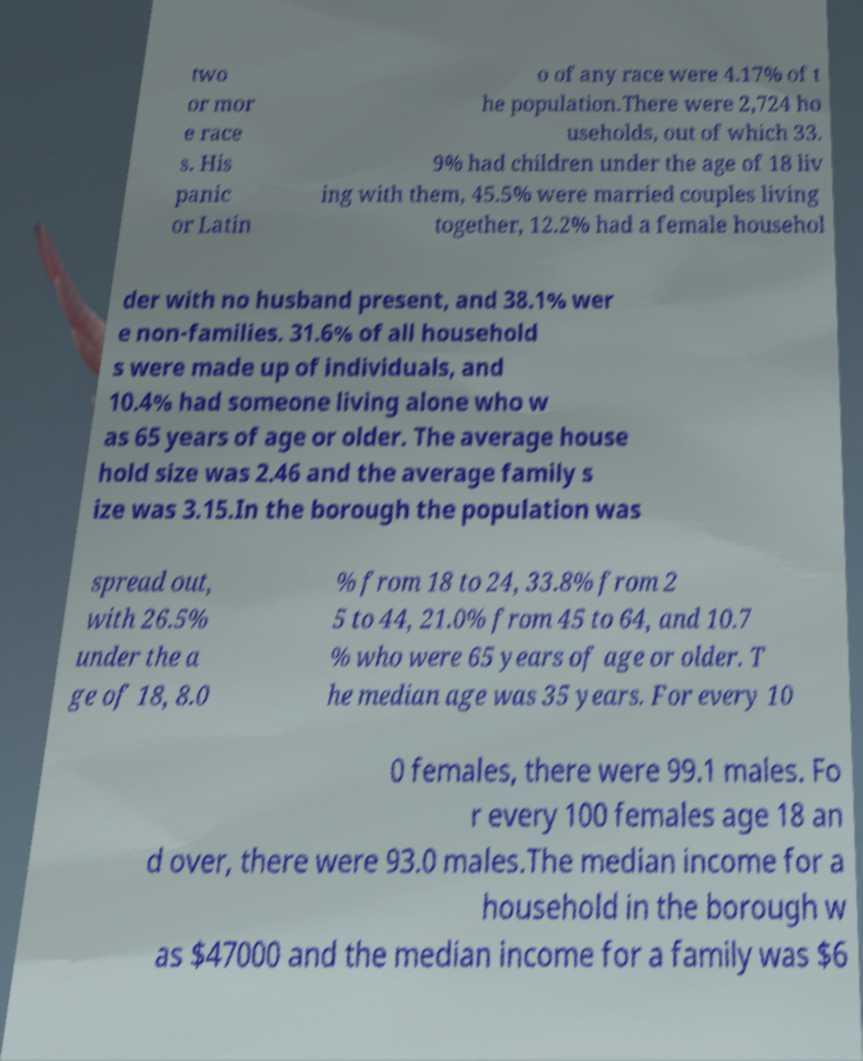There's text embedded in this image that I need extracted. Can you transcribe it verbatim? two or mor e race s. His panic or Latin o of any race were 4.17% of t he population.There were 2,724 ho useholds, out of which 33. 9% had children under the age of 18 liv ing with them, 45.5% were married couples living together, 12.2% had a female househol der with no husband present, and 38.1% wer e non-families. 31.6% of all household s were made up of individuals, and 10.4% had someone living alone who w as 65 years of age or older. The average house hold size was 2.46 and the average family s ize was 3.15.In the borough the population was spread out, with 26.5% under the a ge of 18, 8.0 % from 18 to 24, 33.8% from 2 5 to 44, 21.0% from 45 to 64, and 10.7 % who were 65 years of age or older. T he median age was 35 years. For every 10 0 females, there were 99.1 males. Fo r every 100 females age 18 an d over, there were 93.0 males.The median income for a household in the borough w as $47000 and the median income for a family was $6 